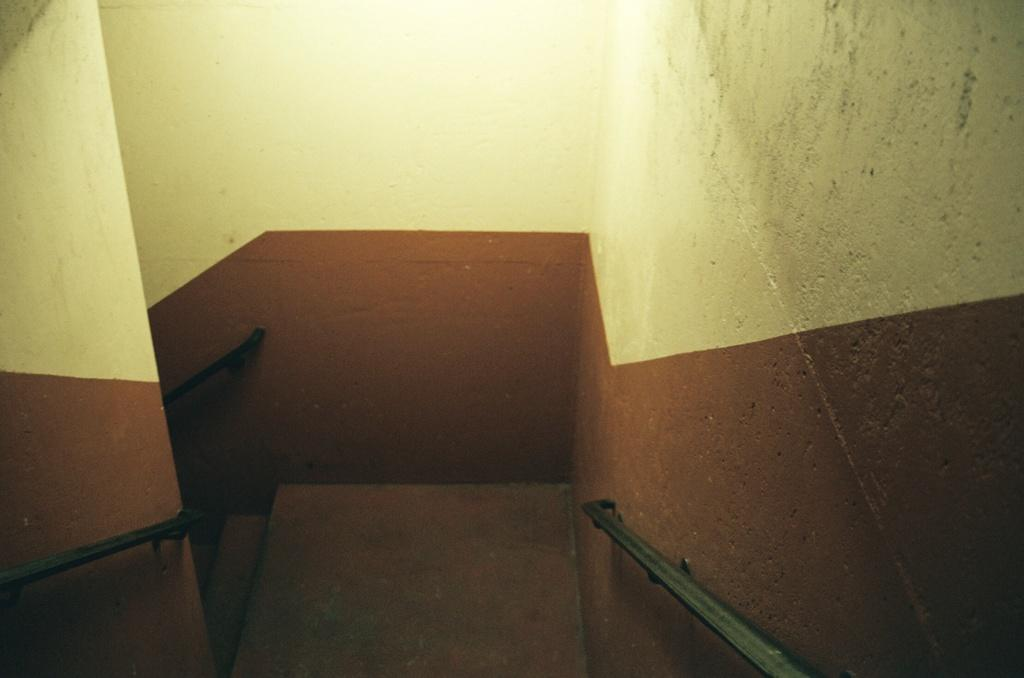What type of structure is present on the stairs in the image? There are metal rods on the left and right sides of the image, which are attached to the wall. How are the metal rods positioned in relation to the stairs? The metal rods are on both sides of the stairs. What material are the rods made of? The rods are made of metal. What type of toy can be seen on the stairs in the image? There is no toy present on the stairs in the image. What kind of fruit is hanging from the metal rods in the image? There is no fruit present in the image; it only features stairs and metal rods. 